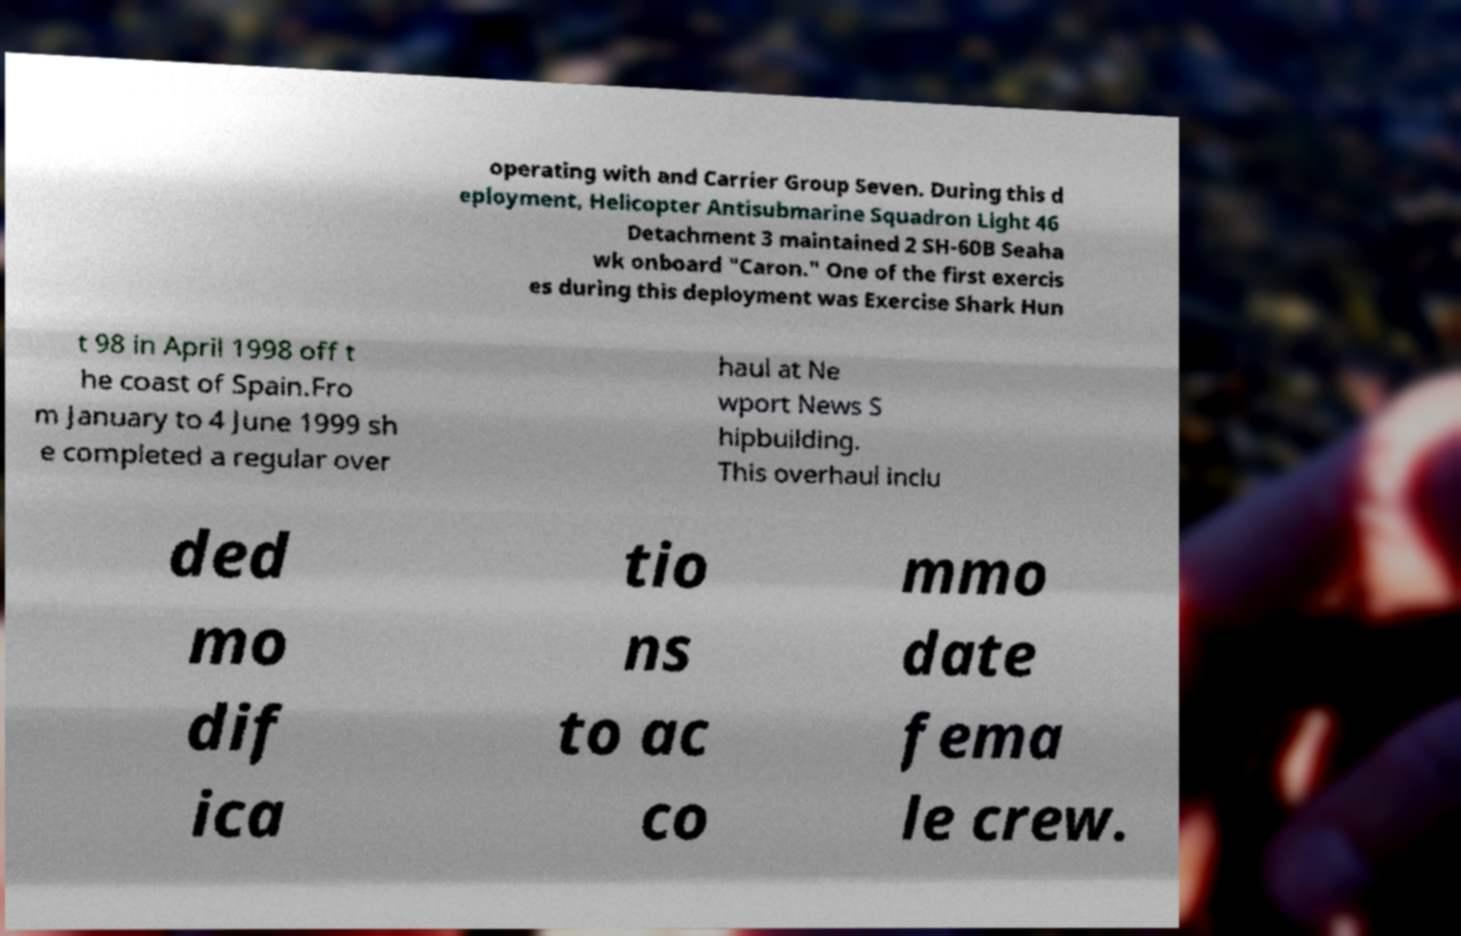Please read and relay the text visible in this image. What does it say? operating with and Carrier Group Seven. During this d eployment, Helicopter Antisubmarine Squadron Light 46 Detachment 3 maintained 2 SH-60B Seaha wk onboard "Caron." One of the first exercis es during this deployment was Exercise Shark Hun t 98 in April 1998 off t he coast of Spain.Fro m January to 4 June 1999 sh e completed a regular over haul at Ne wport News S hipbuilding. This overhaul inclu ded mo dif ica tio ns to ac co mmo date fema le crew. 